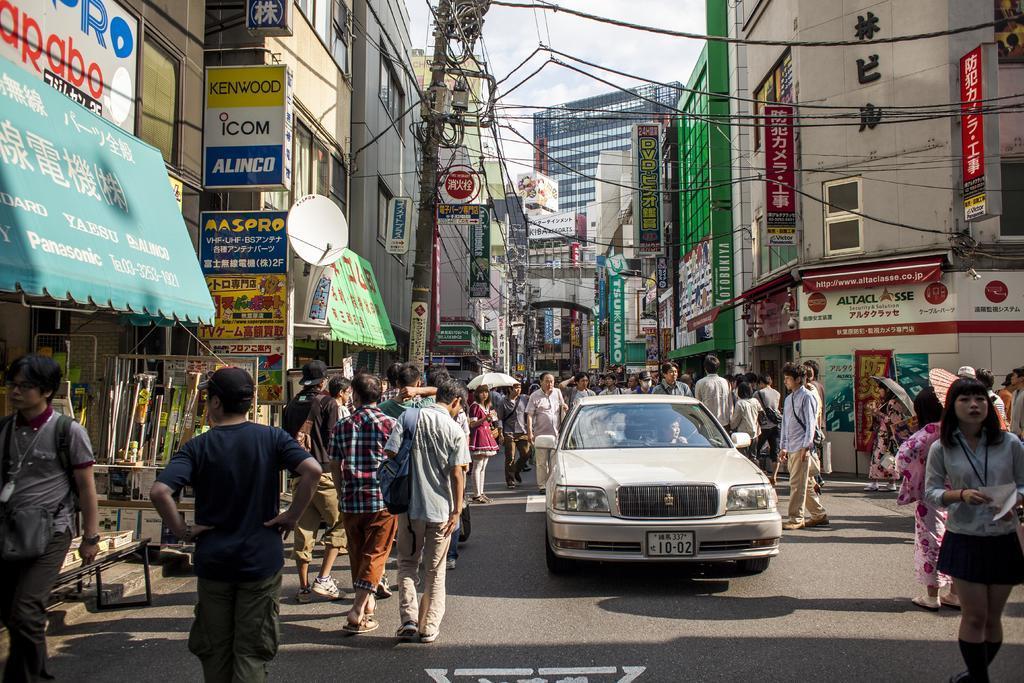Describe this image in one or two sentences. In the middle of the image there is a car. There are two persons sitting inside the car. A woman is standing and holding an umbrella. At the right side there is a woman walking is wearing a shirt. At the left side there is a man walking. There are group of people on the road. At the background there are buildings. At the top there is sky. There is a pole with the wires. 